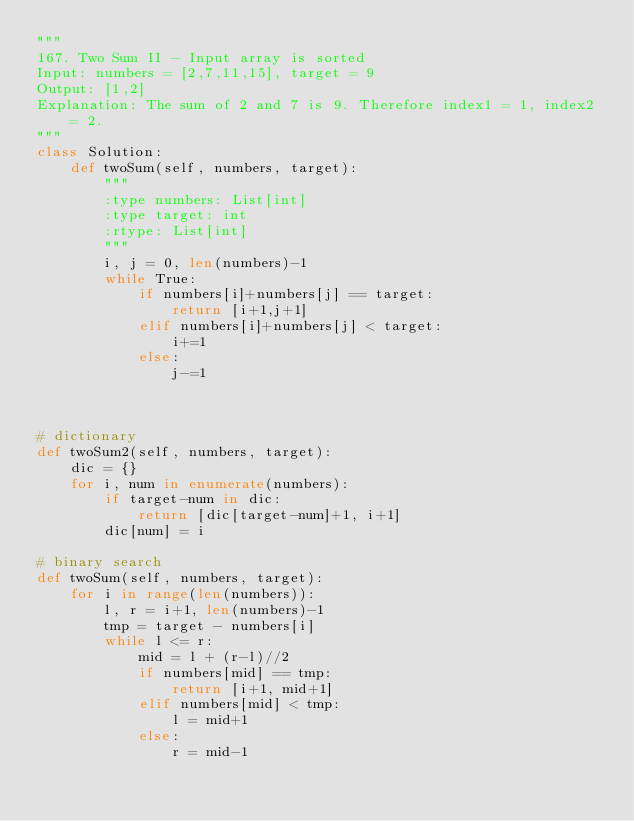<code> <loc_0><loc_0><loc_500><loc_500><_Python_>"""
167. Two Sum II - Input array is sorted
Input: numbers = [2,7,11,15], target = 9
Output: [1,2]
Explanation: The sum of 2 and 7 is 9. Therefore index1 = 1, index2 = 2.
"""
class Solution:
    def twoSum(self, numbers, target):
        """
        :type numbers: List[int]
        :type target: int
        :rtype: List[int]
        """
        i, j = 0, len(numbers)-1
        while True:
            if numbers[i]+numbers[j] == target:
                return [i+1,j+1]
            elif numbers[i]+numbers[j] < target:
                i+=1
            else: 
                j-=1


 
# dictionary           
def twoSum2(self, numbers, target):
    dic = {}
    for i, num in enumerate(numbers):
        if target-num in dic:
            return [dic[target-num]+1, i+1]
        dic[num] = i
 
# binary search        
def twoSum(self, numbers, target):
    for i in range(len(numbers)):
        l, r = i+1, len(numbers)-1
        tmp = target - numbers[i]
        while l <= r:
            mid = l + (r-l)//2
            if numbers[mid] == tmp:
                return [i+1, mid+1]
            elif numbers[mid] < tmp:
                l = mid+1
            else:
                r = mid-1</code> 